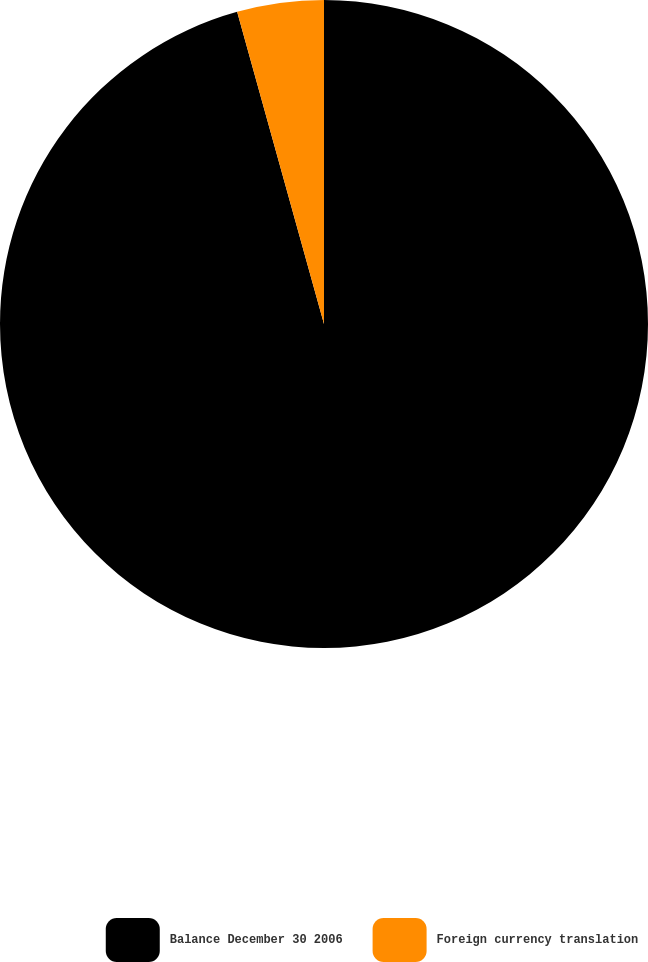Convert chart. <chart><loc_0><loc_0><loc_500><loc_500><pie_chart><fcel>Balance December 30 2006<fcel>Foreign currency translation<nl><fcel>95.68%<fcel>4.32%<nl></chart> 